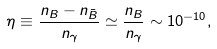Convert formula to latex. <formula><loc_0><loc_0><loc_500><loc_500>\eta \equiv \frac { n _ { B } - n _ { \bar { B } } } { n _ { \gamma } } \simeq \frac { n _ { B } } { n _ { \gamma } } \sim 1 0 ^ { - 1 0 } ,</formula> 